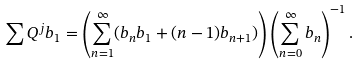<formula> <loc_0><loc_0><loc_500><loc_500>\sum Q ^ { j } b _ { 1 } = \left ( \sum _ { n = 1 } ^ { \infty } ( b _ { n } b _ { 1 } + ( n - 1 ) b _ { n + 1 } ) \right ) \left ( \sum _ { n = 0 } ^ { \infty } b _ { n } \right ) ^ { - 1 } .</formula> 